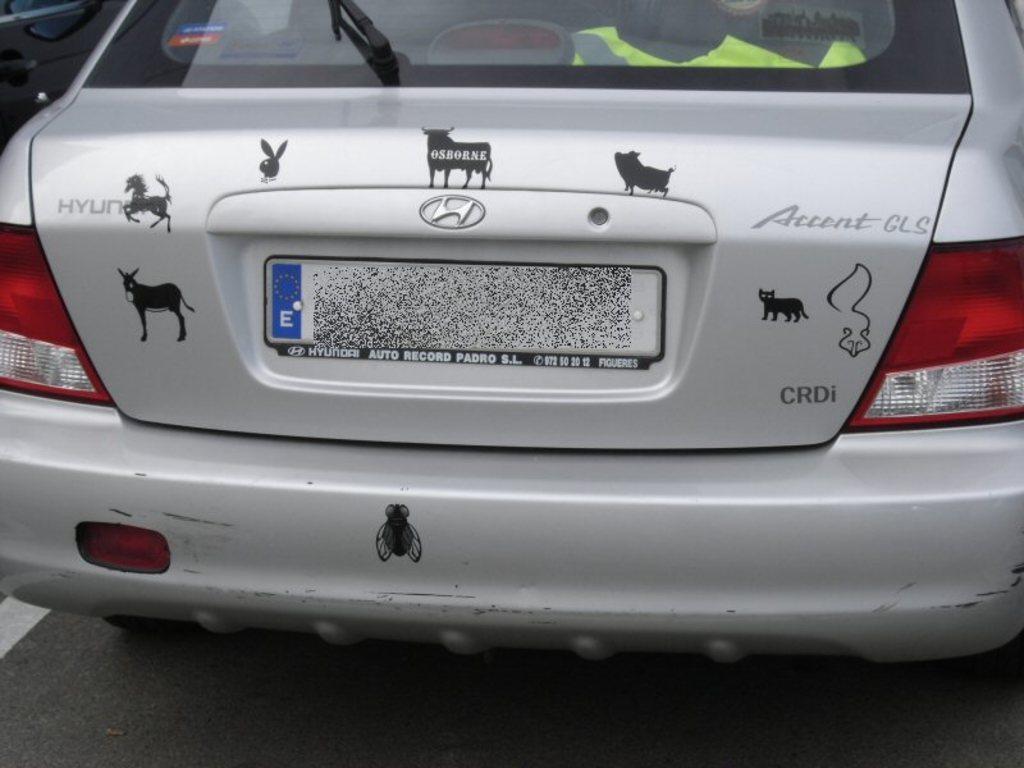How would you summarize this image in a sentence or two? In this image we can see the back side view of a car, in this image we can see windshield, wind viper, two tail lamps. 